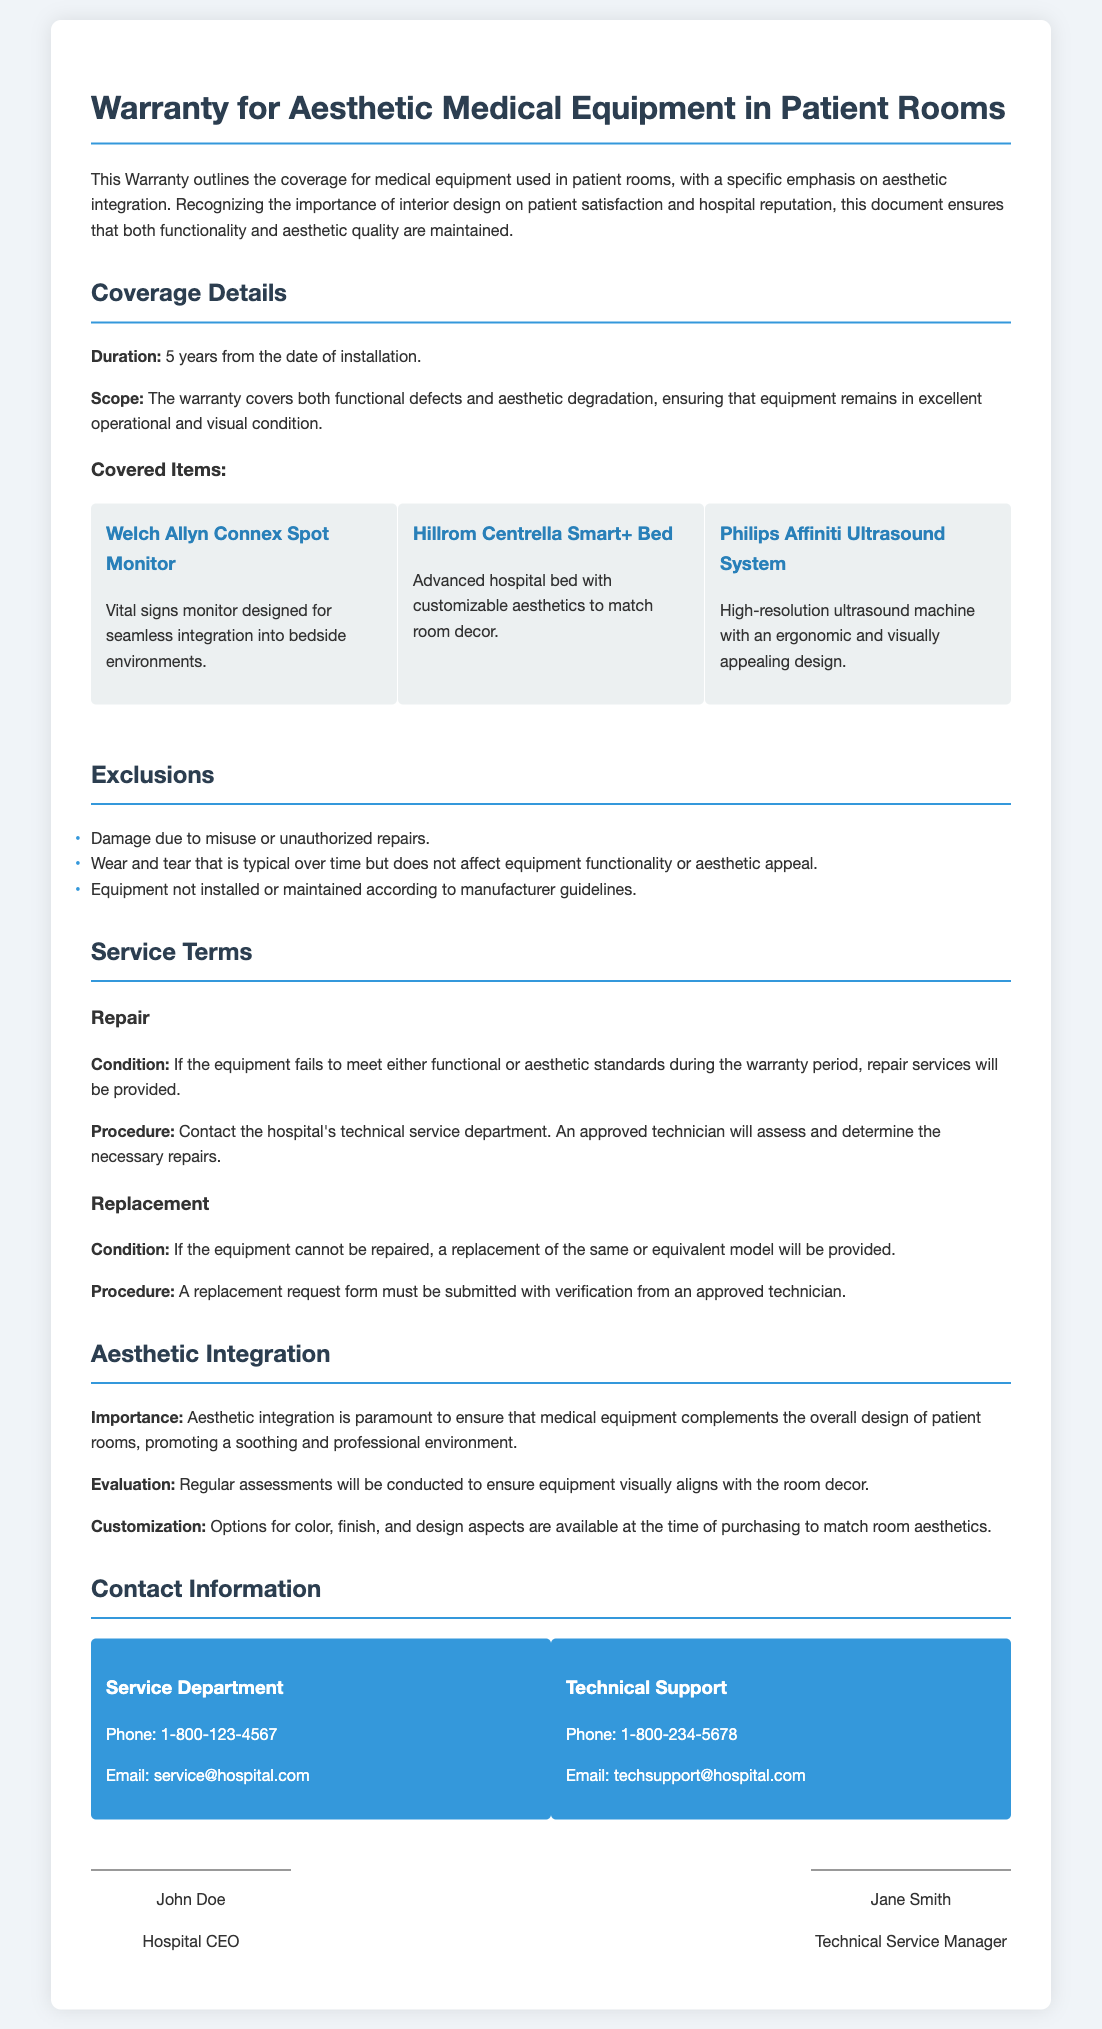what is the duration of the warranty? The duration of the warranty is explicitly stated in the document, which is 5 years from the date of installation.
Answer: 5 years which item is designed for seamless integration into bedside environments? The item specifically mentioned for seamless integration into bedside environments is the Welch Allyn Connex Spot Monitor.
Answer: Welch Allyn Connex Spot Monitor what type of wear is excluded from the warranty? The document lists exclusions, including wear and tear that is typical over time but does not affect equipment functionality or aesthetic appeal.
Answer: Typical wear and tear what is the phone number for the Service Department? The Service Department's contact information includes a phone number that is listed as 1-800-123-4567.
Answer: 1-800-123-4567 what must be submitted for a replacement request? The procedure states that a replacement request form must be submitted with verification from an approved technician.
Answer: Replacement request form why is aesthetic integration important in the warranty? The document mentions that aesthetic integration is crucial to ensure that medical equipment complements the overall design of patient rooms, promoting a soothing and professional environment.
Answer: To ensure visual alignment with room design who is the Technical Service Manager? The document concludes with signatures, identifying Jane Smith as the Technical Service Manager.
Answer: Jane Smith 